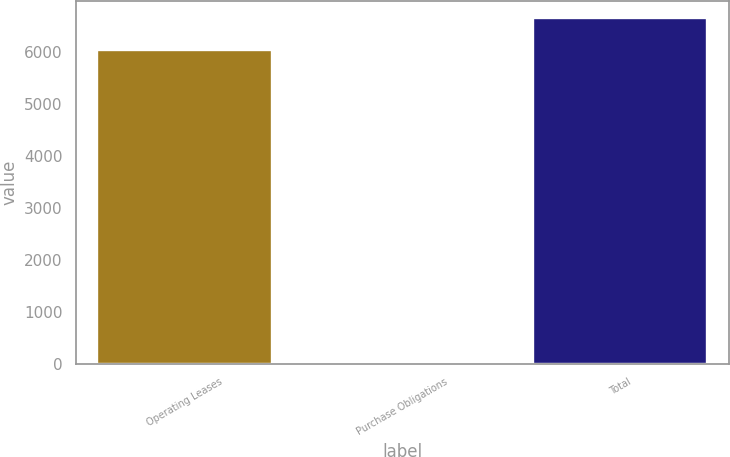Convert chart to OTSL. <chart><loc_0><loc_0><loc_500><loc_500><bar_chart><fcel>Operating Leases<fcel>Purchase Obligations<fcel>Total<nl><fcel>6040<fcel>0.73<fcel>6643.93<nl></chart> 